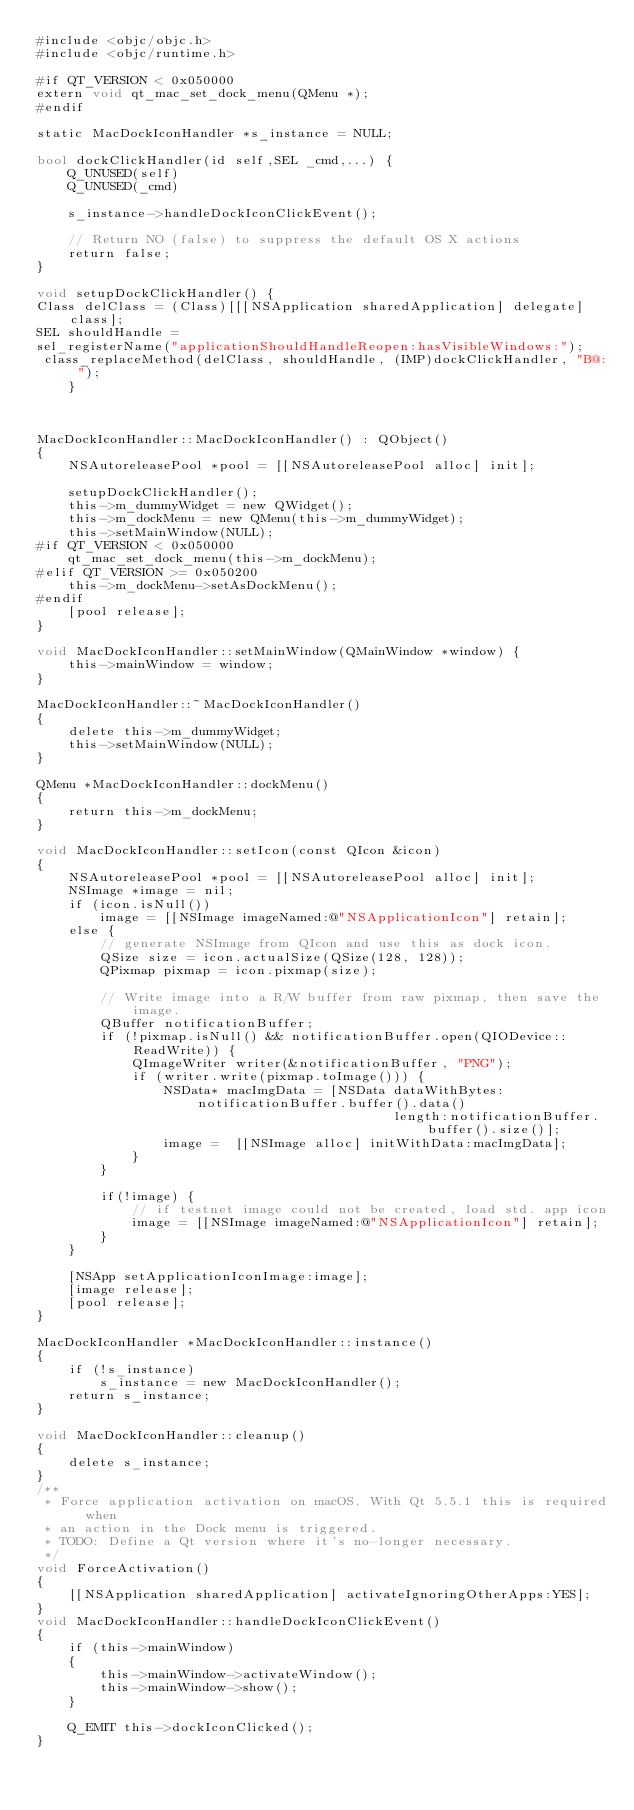Convert code to text. <code><loc_0><loc_0><loc_500><loc_500><_ObjectiveC_>#include <objc/objc.h>	
#include <objc/runtime.h>

#if QT_VERSION < 0x050000
extern void qt_mac_set_dock_menu(QMenu *);
#endif

static MacDockIconHandler *s_instance = NULL;

bool dockClickHandler(id self,SEL _cmd,...) {
    Q_UNUSED(self)
    Q_UNUSED(_cmd)
    
    s_instance->handleDockIconClickEvent();
    
    // Return NO (false) to suppress the default OS X actions
    return false;
}

void setupDockClickHandler() {
Class delClass = (Class)[[[NSApplication sharedApplication] delegate] class];
SEL shouldHandle = 
sel_registerName("applicationShouldHandleReopen:hasVisibleWindows:");
 class_replaceMethod(delClass, shouldHandle, (IMP)dockClickHandler, "B@:");
  	}



MacDockIconHandler::MacDockIconHandler() : QObject()
{
    NSAutoreleasePool *pool = [[NSAutoreleasePool alloc] init];

    setupDockClickHandler();
    this->m_dummyWidget = new QWidget();
    this->m_dockMenu = new QMenu(this->m_dummyWidget);
    this->setMainWindow(NULL);
#if QT_VERSION < 0x050000
    qt_mac_set_dock_menu(this->m_dockMenu);
#elif QT_VERSION >= 0x050200
    this->m_dockMenu->setAsDockMenu();
#endif
    [pool release];
}

void MacDockIconHandler::setMainWindow(QMainWindow *window) {
    this->mainWindow = window;
}

MacDockIconHandler::~MacDockIconHandler()
{
    delete this->m_dummyWidget;
    this->setMainWindow(NULL);
}

QMenu *MacDockIconHandler::dockMenu()
{
    return this->m_dockMenu;
}

void MacDockIconHandler::setIcon(const QIcon &icon)
{
    NSAutoreleasePool *pool = [[NSAutoreleasePool alloc] init];
    NSImage *image = nil;
    if (icon.isNull())
        image = [[NSImage imageNamed:@"NSApplicationIcon"] retain];
    else {
        // generate NSImage from QIcon and use this as dock icon.
        QSize size = icon.actualSize(QSize(128, 128));
        QPixmap pixmap = icon.pixmap(size);

        // Write image into a R/W buffer from raw pixmap, then save the image.
        QBuffer notificationBuffer;
        if (!pixmap.isNull() && notificationBuffer.open(QIODevice::ReadWrite)) {
            QImageWriter writer(&notificationBuffer, "PNG");
            if (writer.write(pixmap.toImage())) {
                NSData* macImgData = [NSData dataWithBytes:notificationBuffer.buffer().data()
                                             length:notificationBuffer.buffer().size()];
                image =  [[NSImage alloc] initWithData:macImgData];
            }
        }

        if(!image) {
            // if testnet image could not be created, load std. app icon
            image = [[NSImage imageNamed:@"NSApplicationIcon"] retain];
        }
    }

    [NSApp setApplicationIconImage:image];
    [image release];
    [pool release];
}

MacDockIconHandler *MacDockIconHandler::instance()
{
    if (!s_instance)
        s_instance = new MacDockIconHandler();
    return s_instance;
}

void MacDockIconHandler::cleanup()
{
    delete s_instance;
}
/**
 * Force application activation on macOS. With Qt 5.5.1 this is required when
 * an action in the Dock menu is triggered.
 * TODO: Define a Qt version where it's no-longer necessary.
 */
void ForceActivation()
{
    [[NSApplication sharedApplication] activateIgnoringOtherApps:YES];
}
void MacDockIconHandler::handleDockIconClickEvent()
{
    if (this->mainWindow)
    {
        this->mainWindow->activateWindow();
        this->mainWindow->show();
    }

    Q_EMIT this->dockIconClicked();
}
</code> 